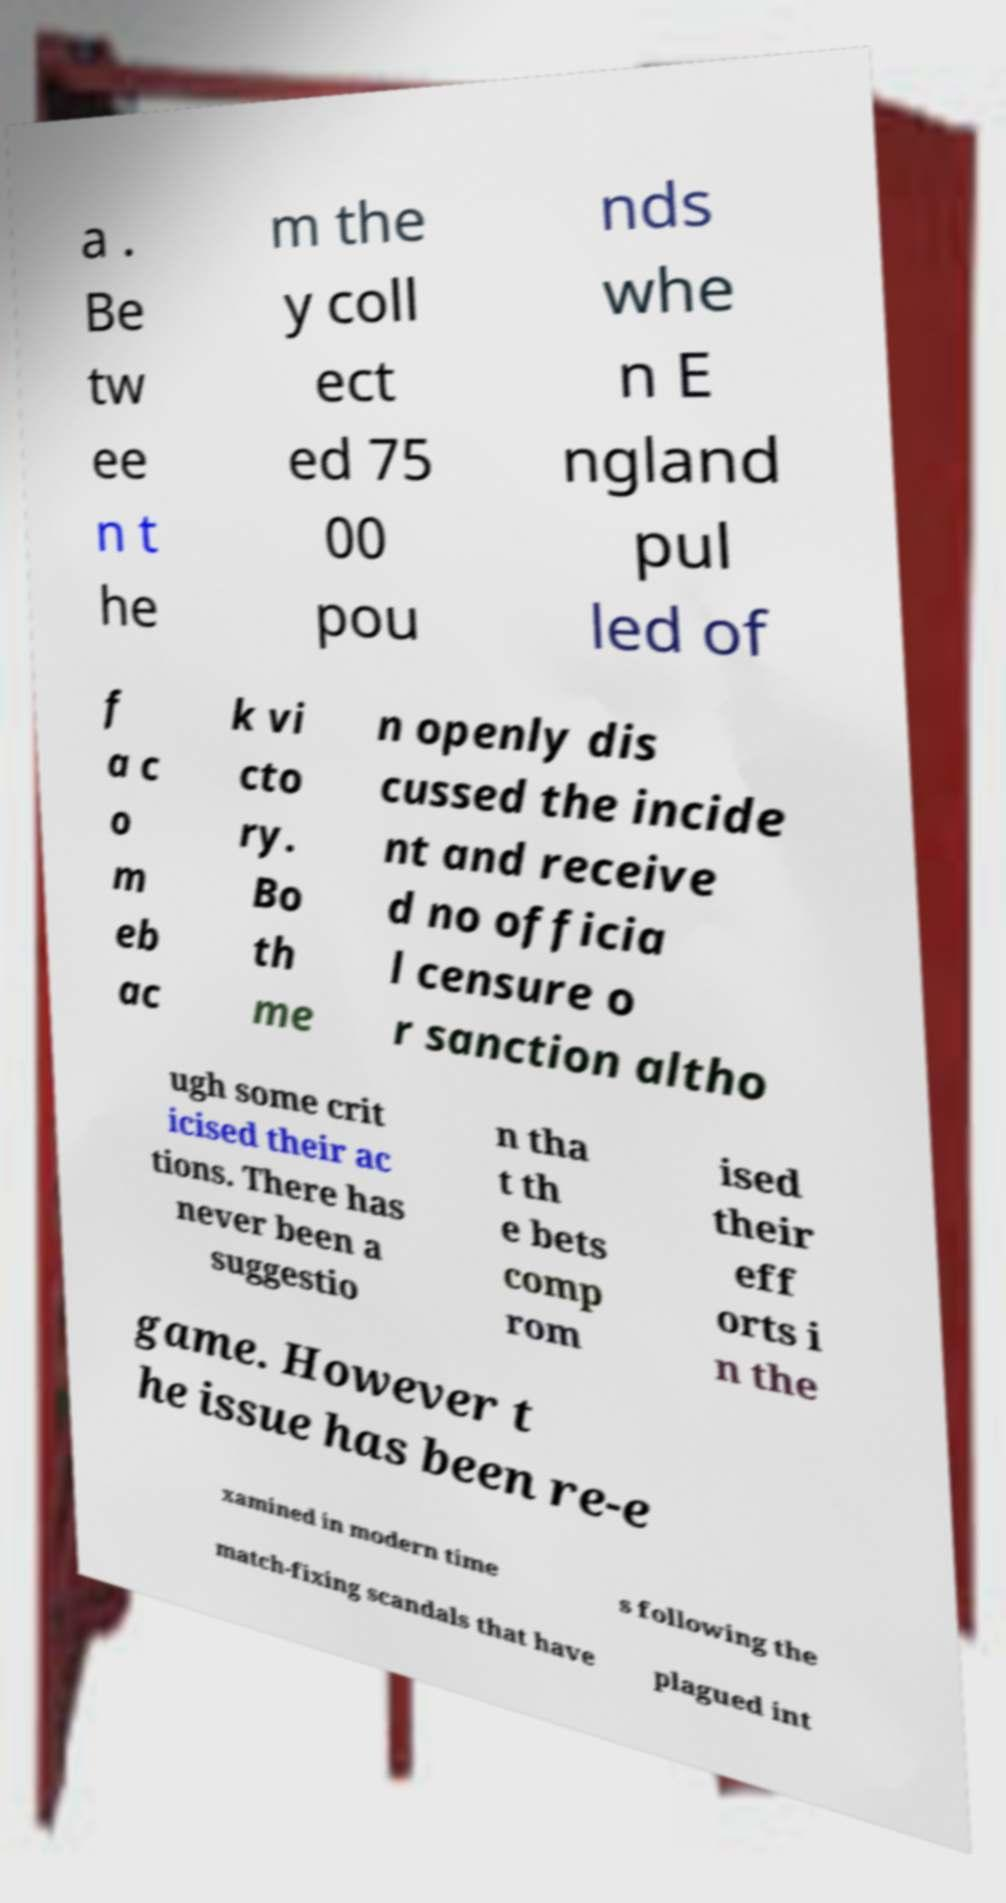What messages or text are displayed in this image? I need them in a readable, typed format. a . Be tw ee n t he m the y coll ect ed 75 00 pou nds whe n E ngland pul led of f a c o m eb ac k vi cto ry. Bo th me n openly dis cussed the incide nt and receive d no officia l censure o r sanction altho ugh some crit icised their ac tions. There has never been a suggestio n tha t th e bets comp rom ised their eff orts i n the game. However t he issue has been re-e xamined in modern time s following the match-fixing scandals that have plagued int 